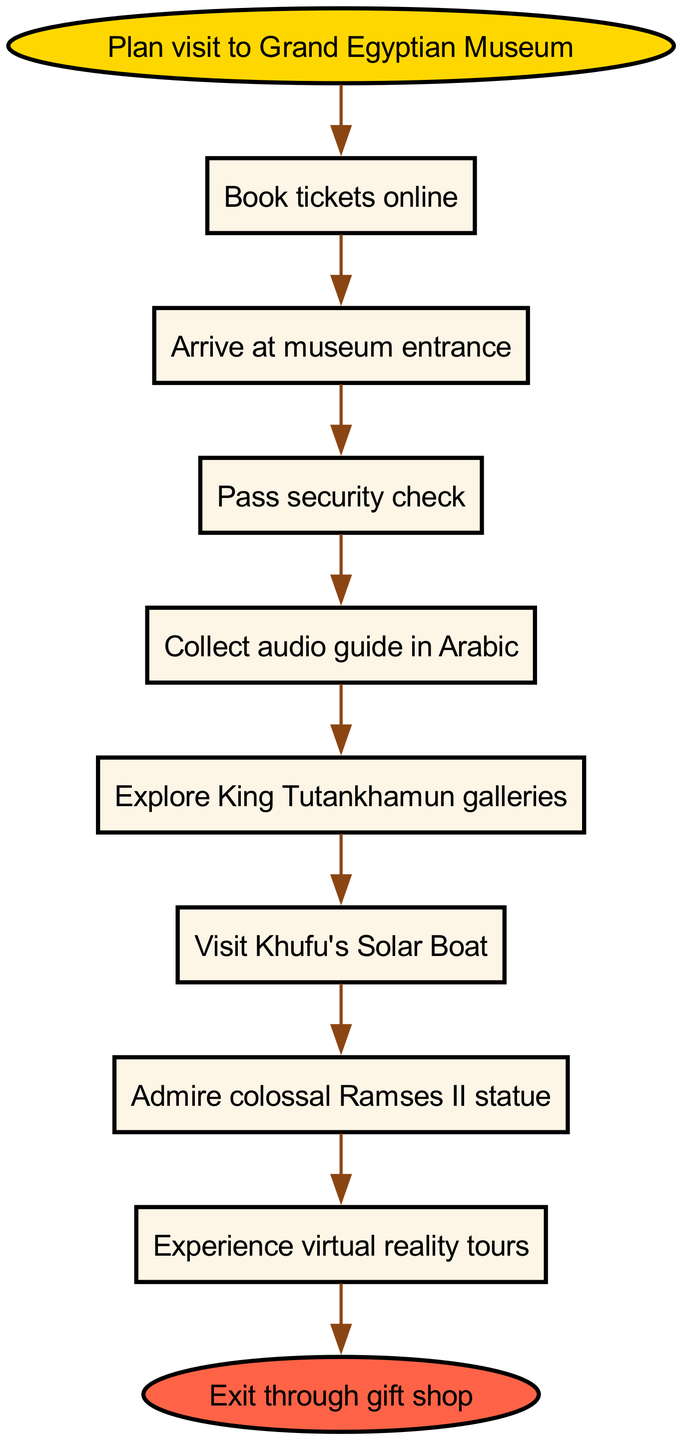What is the first step in the procedure? The diagram indicates that the first step is to "Book tickets online," which is the node immediately following the start node. Therefore, this is where visitors begin their visit procedure.
Answer: Book tickets online How many steps are there in total after planning the visit? The flowchart outlines a sequence of actions starting from "Book tickets online" to "Exit through gift shop." Counting all distinct steps from the first action to the last action results in a total of 8 steps.
Answer: 8 What do you collect after passing the security check? The diagram specifies that after the "Pass security check," the next action is to "Collect audio guide in Arabic." This explicitly indicates that visitors must collect the audio guide at this stage.
Answer: Collect audio guide in Arabic What does the last step involve? According to the diagram, the last step is "Exit through gift shop," indicating that visitors conclude their museum experience by going through the gift shop.
Answer: Exit through gift shop Which gallery is explored after collecting the audio guide? The diagram shows that the step following "Collect audio guide in Arabic" is "Explore King Tutankhamun galleries." This indicates a specific sequence in the exploration process.
Answer: Explore King Tutankhamun galleries What is the relationship between visiting Khufu's Solar Boat and admiring the Ramses II statue? The flowchart establishes that the step to "Visit Khufu's Solar Boat" precedes the step to "Admire colossal Ramses II statue." This indicates a direct sequential flow from one action to the next.
Answer: Sequential relationship What activity comes before experiencing virtual reality tours? Looking at the flowchart, one can see that the step "Admire colossal Ramses II statue" comes directly before the "Experience virtual reality tours." This requires tracking the order of steps in the diagram.
Answer: Admire colossal Ramses II statue In which language is the audio guide available? The diagram specifically mentions that visitors should "Collect audio guide in Arabic" after passing the security check, indicating the language of the audio guide.
Answer: Arabic What is the significance of the start node? The start node, labeled "Plan visit to Grand Egyptian Museum," indicates the initial action or decision required before any other steps can be followed in the procedure.
Answer: Initial action 